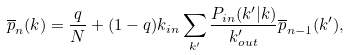Convert formula to latex. <formula><loc_0><loc_0><loc_500><loc_500>\overline { p } _ { n } ( { k } ) = \frac { q } { N } + ( 1 - q ) k _ { i n } \sum _ { k ^ { \prime } } \frac { P _ { i n } ( { k ^ { \prime } } | { k } ) } { k ^ { \prime } _ { o u t } } \overline { p } _ { n - 1 } ( { k ^ { \prime } } ) ,</formula> 